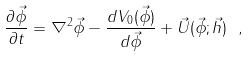Convert formula to latex. <formula><loc_0><loc_0><loc_500><loc_500>\frac { \partial \vec { \phi } } { \partial t } = \nabla ^ { 2 } \vec { \phi } - \frac { d V _ { 0 } ( \vec { \phi } ) } { d \vec { \phi } } + \vec { U } ( \vec { \phi } ; \vec { h } ) \ ,</formula> 